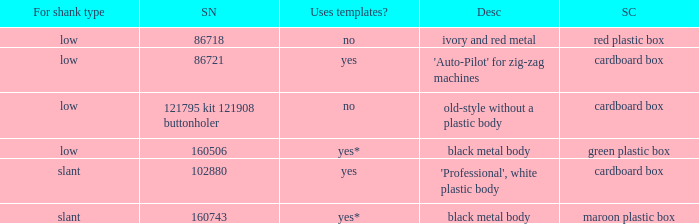I'm looking to parse the entire table for insights. Could you assist me with that? {'header': ['For shank type', 'SN', 'Uses templates?', 'Desc', 'SC'], 'rows': [['low', '86718', 'no', 'ivory and red metal', 'red plastic box'], ['low', '86721', 'yes', "'Auto-Pilot' for zig-zag machines", 'cardboard box'], ['low', '121795 kit 121908 buttonholer', 'no', 'old-style without a plastic body', 'cardboard box'], ['low', '160506', 'yes*', 'black metal body', 'green plastic box'], ['slant', '102880', 'yes', "'Professional', white plastic body", 'cardboard box'], ['slant', '160743', 'yes*', 'black metal body', 'maroon plastic box']]} What's the description of the buttonholer whose singer part number is 121795 kit 121908 buttonholer? Old-style without a plastic body. 